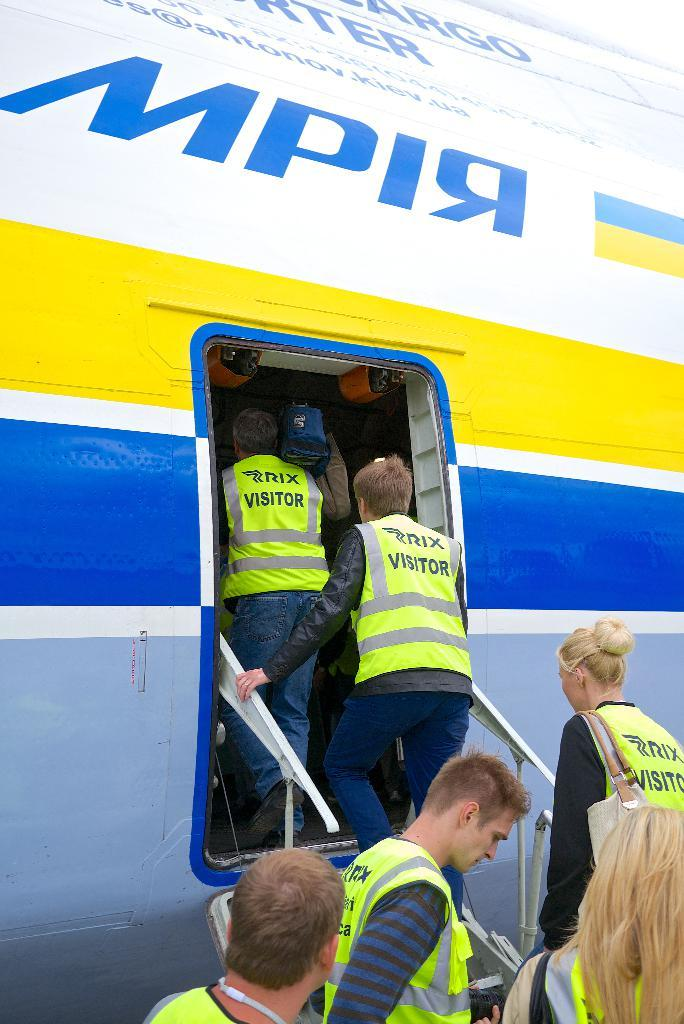Who or what can be seen in the image? There are people in the image. What are the people doing in the image? The people are boarding a plane. What type of brass instrument is being played by the people in the image? There is no brass instrument present in the image; the people are boarding a plane. 